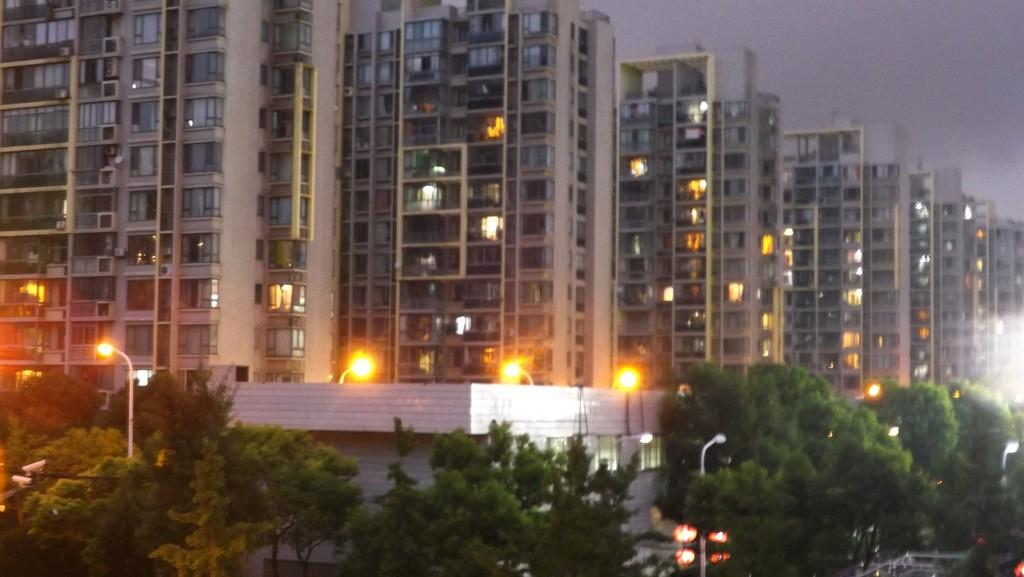What type of natural elements can be seen in the image? There are trees in the image. What man-made object is present in the image? There is a lamp post in the image. What type of structures are visible in the image? There are buildings in the image. How many chairs are placed around the beast in the image? There is no beast or chairs present in the image. What color is the sock on the tree in the image? There is no sock present in the image. 